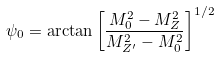Convert formula to latex. <formula><loc_0><loc_0><loc_500><loc_500>\psi _ { 0 } = \arctan \left [ \frac { M _ { 0 } ^ { 2 } - M _ { Z } ^ { 2 } } { M _ { Z ^ { \prime } } ^ { 2 } - M _ { 0 } ^ { 2 } } \right ] ^ { 1 / 2 }</formula> 